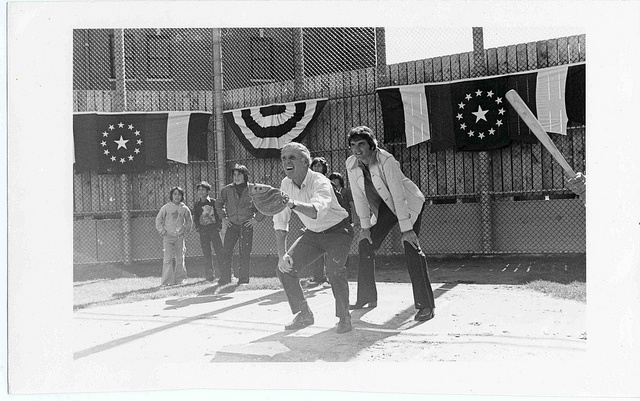Describe the objects in this image and their specific colors. I can see people in white, gray, darkgray, black, and lightgray tones, people in white, gray, darkgray, lightgray, and black tones, people in white, gray, black, and lightgray tones, people in white, darkgray, gray, lightgray, and black tones, and people in white, gray, darkgray, black, and lightgray tones in this image. 